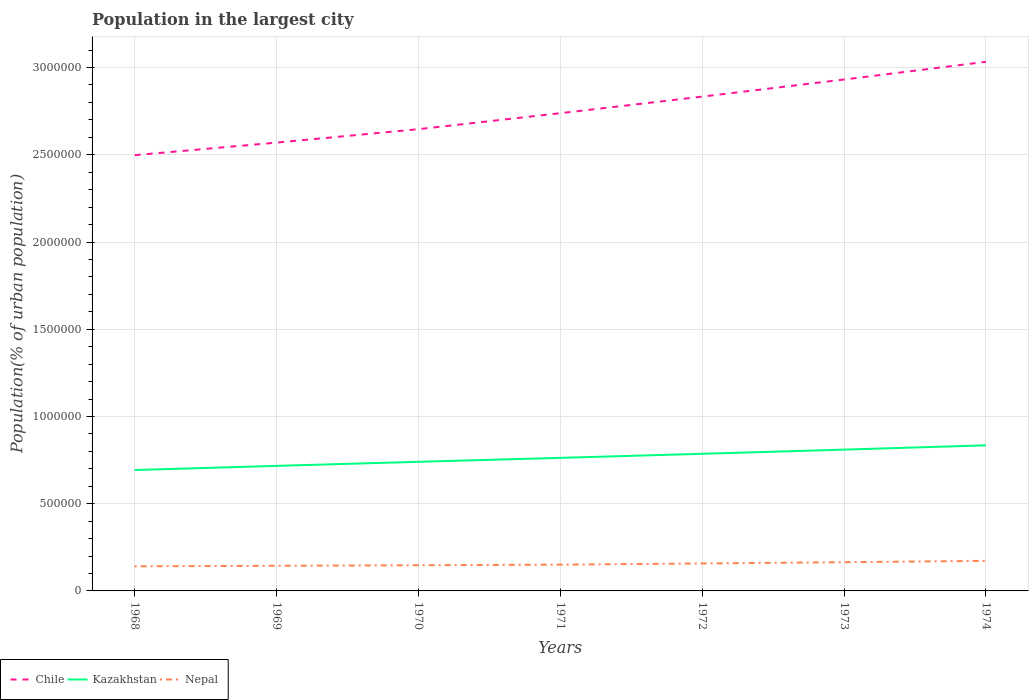Across all years, what is the maximum population in the largest city in Kazakhstan?
Your response must be concise. 6.93e+05. In which year was the population in the largest city in Nepal maximum?
Provide a succinct answer. 1968. What is the total population in the largest city in Nepal in the graph?
Provide a short and direct response. -2.06e+04. What is the difference between the highest and the second highest population in the largest city in Kazakhstan?
Offer a very short reply. 1.42e+05. Is the population in the largest city in Kazakhstan strictly greater than the population in the largest city in Chile over the years?
Your response must be concise. Yes. How many lines are there?
Offer a terse response. 3. Are the values on the major ticks of Y-axis written in scientific E-notation?
Your response must be concise. No. Does the graph contain any zero values?
Your response must be concise. No. What is the title of the graph?
Your answer should be compact. Population in the largest city. Does "Venezuela" appear as one of the legend labels in the graph?
Give a very brief answer. No. What is the label or title of the Y-axis?
Your response must be concise. Population(% of urban population). What is the Population(% of urban population) of Chile in 1968?
Offer a very short reply. 2.50e+06. What is the Population(% of urban population) of Kazakhstan in 1968?
Make the answer very short. 6.93e+05. What is the Population(% of urban population) of Nepal in 1968?
Give a very brief answer. 1.41e+05. What is the Population(% of urban population) in Chile in 1969?
Offer a terse response. 2.57e+06. What is the Population(% of urban population) in Kazakhstan in 1969?
Provide a short and direct response. 7.17e+05. What is the Population(% of urban population) in Nepal in 1969?
Make the answer very short. 1.44e+05. What is the Population(% of urban population) in Chile in 1970?
Make the answer very short. 2.65e+06. What is the Population(% of urban population) in Kazakhstan in 1970?
Your answer should be very brief. 7.40e+05. What is the Population(% of urban population) of Nepal in 1970?
Provide a short and direct response. 1.47e+05. What is the Population(% of urban population) of Chile in 1971?
Offer a very short reply. 2.74e+06. What is the Population(% of urban population) in Kazakhstan in 1971?
Ensure brevity in your answer.  7.63e+05. What is the Population(% of urban population) of Nepal in 1971?
Make the answer very short. 1.51e+05. What is the Population(% of urban population) of Chile in 1972?
Make the answer very short. 2.83e+06. What is the Population(% of urban population) of Kazakhstan in 1972?
Provide a succinct answer. 7.86e+05. What is the Population(% of urban population) in Nepal in 1972?
Give a very brief answer. 1.57e+05. What is the Population(% of urban population) of Chile in 1973?
Your response must be concise. 2.93e+06. What is the Population(% of urban population) of Kazakhstan in 1973?
Your answer should be compact. 8.10e+05. What is the Population(% of urban population) of Nepal in 1973?
Keep it short and to the point. 1.65e+05. What is the Population(% of urban population) of Chile in 1974?
Give a very brief answer. 3.03e+06. What is the Population(% of urban population) in Kazakhstan in 1974?
Provide a short and direct response. 8.35e+05. What is the Population(% of urban population) in Nepal in 1974?
Your response must be concise. 1.72e+05. Across all years, what is the maximum Population(% of urban population) of Chile?
Make the answer very short. 3.03e+06. Across all years, what is the maximum Population(% of urban population) of Kazakhstan?
Offer a terse response. 8.35e+05. Across all years, what is the maximum Population(% of urban population) in Nepal?
Offer a very short reply. 1.72e+05. Across all years, what is the minimum Population(% of urban population) of Chile?
Provide a succinct answer. 2.50e+06. Across all years, what is the minimum Population(% of urban population) in Kazakhstan?
Keep it short and to the point. 6.93e+05. Across all years, what is the minimum Population(% of urban population) of Nepal?
Your response must be concise. 1.41e+05. What is the total Population(% of urban population) in Chile in the graph?
Provide a short and direct response. 1.93e+07. What is the total Population(% of urban population) in Kazakhstan in the graph?
Offer a very short reply. 5.34e+06. What is the total Population(% of urban population) in Nepal in the graph?
Give a very brief answer. 1.08e+06. What is the difference between the Population(% of urban population) in Chile in 1968 and that in 1969?
Provide a succinct answer. -7.19e+04. What is the difference between the Population(% of urban population) of Kazakhstan in 1968 and that in 1969?
Offer a terse response. -2.38e+04. What is the difference between the Population(% of urban population) of Nepal in 1968 and that in 1969?
Provide a succinct answer. -3094. What is the difference between the Population(% of urban population) in Chile in 1968 and that in 1970?
Your response must be concise. -1.49e+05. What is the difference between the Population(% of urban population) of Kazakhstan in 1968 and that in 1970?
Give a very brief answer. -4.72e+04. What is the difference between the Population(% of urban population) in Nepal in 1968 and that in 1970?
Offer a terse response. -6260. What is the difference between the Population(% of urban population) of Chile in 1968 and that in 1971?
Ensure brevity in your answer.  -2.41e+05. What is the difference between the Population(% of urban population) of Kazakhstan in 1968 and that in 1971?
Ensure brevity in your answer.  -6.98e+04. What is the difference between the Population(% of urban population) of Nepal in 1968 and that in 1971?
Your answer should be very brief. -9581. What is the difference between the Population(% of urban population) in Chile in 1968 and that in 1972?
Keep it short and to the point. -3.36e+05. What is the difference between the Population(% of urban population) in Kazakhstan in 1968 and that in 1972?
Your answer should be very brief. -9.30e+04. What is the difference between the Population(% of urban population) in Nepal in 1968 and that in 1972?
Offer a very short reply. -1.65e+04. What is the difference between the Population(% of urban population) of Chile in 1968 and that in 1973?
Give a very brief answer. -4.34e+05. What is the difference between the Population(% of urban population) in Kazakhstan in 1968 and that in 1973?
Your answer should be very brief. -1.17e+05. What is the difference between the Population(% of urban population) of Nepal in 1968 and that in 1973?
Provide a succinct answer. -2.37e+04. What is the difference between the Population(% of urban population) in Chile in 1968 and that in 1974?
Offer a terse response. -5.35e+05. What is the difference between the Population(% of urban population) in Kazakhstan in 1968 and that in 1974?
Your answer should be compact. -1.42e+05. What is the difference between the Population(% of urban population) of Nepal in 1968 and that in 1974?
Give a very brief answer. -3.12e+04. What is the difference between the Population(% of urban population) in Chile in 1969 and that in 1970?
Ensure brevity in your answer.  -7.69e+04. What is the difference between the Population(% of urban population) in Kazakhstan in 1969 and that in 1970?
Your answer should be very brief. -2.34e+04. What is the difference between the Population(% of urban population) in Nepal in 1969 and that in 1970?
Your answer should be very brief. -3166. What is the difference between the Population(% of urban population) of Chile in 1969 and that in 1971?
Keep it short and to the point. -1.69e+05. What is the difference between the Population(% of urban population) in Kazakhstan in 1969 and that in 1971?
Make the answer very short. -4.59e+04. What is the difference between the Population(% of urban population) of Nepal in 1969 and that in 1971?
Ensure brevity in your answer.  -6487. What is the difference between the Population(% of urban population) of Chile in 1969 and that in 1972?
Offer a very short reply. -2.64e+05. What is the difference between the Population(% of urban population) in Kazakhstan in 1969 and that in 1972?
Provide a short and direct response. -6.92e+04. What is the difference between the Population(% of urban population) of Nepal in 1969 and that in 1972?
Your response must be concise. -1.34e+04. What is the difference between the Population(% of urban population) of Chile in 1969 and that in 1973?
Your answer should be very brief. -3.62e+05. What is the difference between the Population(% of urban population) in Kazakhstan in 1969 and that in 1973?
Offer a very short reply. -9.32e+04. What is the difference between the Population(% of urban population) of Nepal in 1969 and that in 1973?
Offer a very short reply. -2.06e+04. What is the difference between the Population(% of urban population) of Chile in 1969 and that in 1974?
Your response must be concise. -4.63e+05. What is the difference between the Population(% of urban population) in Kazakhstan in 1969 and that in 1974?
Your answer should be compact. -1.18e+05. What is the difference between the Population(% of urban population) in Nepal in 1969 and that in 1974?
Provide a succinct answer. -2.81e+04. What is the difference between the Population(% of urban population) in Chile in 1970 and that in 1971?
Offer a very short reply. -9.17e+04. What is the difference between the Population(% of urban population) of Kazakhstan in 1970 and that in 1971?
Ensure brevity in your answer.  -2.26e+04. What is the difference between the Population(% of urban population) in Nepal in 1970 and that in 1971?
Your response must be concise. -3321. What is the difference between the Population(% of urban population) of Chile in 1970 and that in 1972?
Keep it short and to the point. -1.87e+05. What is the difference between the Population(% of urban population) in Kazakhstan in 1970 and that in 1972?
Provide a succinct answer. -4.59e+04. What is the difference between the Population(% of urban population) in Nepal in 1970 and that in 1972?
Your answer should be very brief. -1.02e+04. What is the difference between the Population(% of urban population) in Chile in 1970 and that in 1973?
Make the answer very short. -2.85e+05. What is the difference between the Population(% of urban population) of Kazakhstan in 1970 and that in 1973?
Provide a short and direct response. -6.98e+04. What is the difference between the Population(% of urban population) of Nepal in 1970 and that in 1973?
Your response must be concise. -1.74e+04. What is the difference between the Population(% of urban population) of Chile in 1970 and that in 1974?
Ensure brevity in your answer.  -3.86e+05. What is the difference between the Population(% of urban population) of Kazakhstan in 1970 and that in 1974?
Ensure brevity in your answer.  -9.45e+04. What is the difference between the Population(% of urban population) in Nepal in 1970 and that in 1974?
Provide a short and direct response. -2.49e+04. What is the difference between the Population(% of urban population) in Chile in 1971 and that in 1972?
Offer a very short reply. -9.50e+04. What is the difference between the Population(% of urban population) in Kazakhstan in 1971 and that in 1972?
Keep it short and to the point. -2.33e+04. What is the difference between the Population(% of urban population) of Nepal in 1971 and that in 1972?
Your answer should be compact. -6892. What is the difference between the Population(% of urban population) of Chile in 1971 and that in 1973?
Your response must be concise. -1.93e+05. What is the difference between the Population(% of urban population) of Kazakhstan in 1971 and that in 1973?
Keep it short and to the point. -4.72e+04. What is the difference between the Population(% of urban population) in Nepal in 1971 and that in 1973?
Ensure brevity in your answer.  -1.41e+04. What is the difference between the Population(% of urban population) in Chile in 1971 and that in 1974?
Your response must be concise. -2.95e+05. What is the difference between the Population(% of urban population) of Kazakhstan in 1971 and that in 1974?
Your answer should be very brief. -7.19e+04. What is the difference between the Population(% of urban population) in Nepal in 1971 and that in 1974?
Your answer should be very brief. -2.16e+04. What is the difference between the Population(% of urban population) of Chile in 1972 and that in 1973?
Keep it short and to the point. -9.80e+04. What is the difference between the Population(% of urban population) in Kazakhstan in 1972 and that in 1973?
Your response must be concise. -2.39e+04. What is the difference between the Population(% of urban population) in Nepal in 1972 and that in 1973?
Make the answer very short. -7187. What is the difference between the Population(% of urban population) in Chile in 1972 and that in 1974?
Ensure brevity in your answer.  -2.00e+05. What is the difference between the Population(% of urban population) in Kazakhstan in 1972 and that in 1974?
Keep it short and to the point. -4.86e+04. What is the difference between the Population(% of urban population) of Nepal in 1972 and that in 1974?
Ensure brevity in your answer.  -1.47e+04. What is the difference between the Population(% of urban population) in Chile in 1973 and that in 1974?
Your answer should be compact. -1.02e+05. What is the difference between the Population(% of urban population) in Kazakhstan in 1973 and that in 1974?
Provide a succinct answer. -2.47e+04. What is the difference between the Population(% of urban population) of Nepal in 1973 and that in 1974?
Offer a very short reply. -7526. What is the difference between the Population(% of urban population) in Chile in 1968 and the Population(% of urban population) in Kazakhstan in 1969?
Offer a very short reply. 1.78e+06. What is the difference between the Population(% of urban population) of Chile in 1968 and the Population(% of urban population) of Nepal in 1969?
Your response must be concise. 2.35e+06. What is the difference between the Population(% of urban population) in Kazakhstan in 1968 and the Population(% of urban population) in Nepal in 1969?
Provide a succinct answer. 5.49e+05. What is the difference between the Population(% of urban population) in Chile in 1968 and the Population(% of urban population) in Kazakhstan in 1970?
Your answer should be very brief. 1.76e+06. What is the difference between the Population(% of urban population) of Chile in 1968 and the Population(% of urban population) of Nepal in 1970?
Make the answer very short. 2.35e+06. What is the difference between the Population(% of urban population) of Kazakhstan in 1968 and the Population(% of urban population) of Nepal in 1970?
Provide a short and direct response. 5.46e+05. What is the difference between the Population(% of urban population) of Chile in 1968 and the Population(% of urban population) of Kazakhstan in 1971?
Your answer should be compact. 1.74e+06. What is the difference between the Population(% of urban population) in Chile in 1968 and the Population(% of urban population) in Nepal in 1971?
Your answer should be compact. 2.35e+06. What is the difference between the Population(% of urban population) in Kazakhstan in 1968 and the Population(% of urban population) in Nepal in 1971?
Your response must be concise. 5.42e+05. What is the difference between the Population(% of urban population) in Chile in 1968 and the Population(% of urban population) in Kazakhstan in 1972?
Provide a short and direct response. 1.71e+06. What is the difference between the Population(% of urban population) in Chile in 1968 and the Population(% of urban population) in Nepal in 1972?
Offer a terse response. 2.34e+06. What is the difference between the Population(% of urban population) in Kazakhstan in 1968 and the Population(% of urban population) in Nepal in 1972?
Provide a short and direct response. 5.35e+05. What is the difference between the Population(% of urban population) in Chile in 1968 and the Population(% of urban population) in Kazakhstan in 1973?
Provide a short and direct response. 1.69e+06. What is the difference between the Population(% of urban population) in Chile in 1968 and the Population(% of urban population) in Nepal in 1973?
Your answer should be very brief. 2.33e+06. What is the difference between the Population(% of urban population) of Kazakhstan in 1968 and the Population(% of urban population) of Nepal in 1973?
Ensure brevity in your answer.  5.28e+05. What is the difference between the Population(% of urban population) of Chile in 1968 and the Population(% of urban population) of Kazakhstan in 1974?
Ensure brevity in your answer.  1.66e+06. What is the difference between the Population(% of urban population) of Chile in 1968 and the Population(% of urban population) of Nepal in 1974?
Offer a very short reply. 2.33e+06. What is the difference between the Population(% of urban population) in Kazakhstan in 1968 and the Population(% of urban population) in Nepal in 1974?
Provide a succinct answer. 5.21e+05. What is the difference between the Population(% of urban population) of Chile in 1969 and the Population(% of urban population) of Kazakhstan in 1970?
Make the answer very short. 1.83e+06. What is the difference between the Population(% of urban population) of Chile in 1969 and the Population(% of urban population) of Nepal in 1970?
Provide a succinct answer. 2.42e+06. What is the difference between the Population(% of urban population) in Kazakhstan in 1969 and the Population(% of urban population) in Nepal in 1970?
Provide a succinct answer. 5.69e+05. What is the difference between the Population(% of urban population) in Chile in 1969 and the Population(% of urban population) in Kazakhstan in 1971?
Give a very brief answer. 1.81e+06. What is the difference between the Population(% of urban population) of Chile in 1969 and the Population(% of urban population) of Nepal in 1971?
Provide a succinct answer. 2.42e+06. What is the difference between the Population(% of urban population) of Kazakhstan in 1969 and the Population(% of urban population) of Nepal in 1971?
Give a very brief answer. 5.66e+05. What is the difference between the Population(% of urban population) in Chile in 1969 and the Population(% of urban population) in Kazakhstan in 1972?
Ensure brevity in your answer.  1.78e+06. What is the difference between the Population(% of urban population) of Chile in 1969 and the Population(% of urban population) of Nepal in 1972?
Your answer should be very brief. 2.41e+06. What is the difference between the Population(% of urban population) of Kazakhstan in 1969 and the Population(% of urban population) of Nepal in 1972?
Your answer should be very brief. 5.59e+05. What is the difference between the Population(% of urban population) in Chile in 1969 and the Population(% of urban population) in Kazakhstan in 1973?
Provide a succinct answer. 1.76e+06. What is the difference between the Population(% of urban population) of Chile in 1969 and the Population(% of urban population) of Nepal in 1973?
Your answer should be compact. 2.41e+06. What is the difference between the Population(% of urban population) of Kazakhstan in 1969 and the Population(% of urban population) of Nepal in 1973?
Make the answer very short. 5.52e+05. What is the difference between the Population(% of urban population) of Chile in 1969 and the Population(% of urban population) of Kazakhstan in 1974?
Offer a terse response. 1.74e+06. What is the difference between the Population(% of urban population) in Chile in 1969 and the Population(% of urban population) in Nepal in 1974?
Provide a short and direct response. 2.40e+06. What is the difference between the Population(% of urban population) of Kazakhstan in 1969 and the Population(% of urban population) of Nepal in 1974?
Offer a terse response. 5.45e+05. What is the difference between the Population(% of urban population) in Chile in 1970 and the Population(% of urban population) in Kazakhstan in 1971?
Your answer should be very brief. 1.88e+06. What is the difference between the Population(% of urban population) of Chile in 1970 and the Population(% of urban population) of Nepal in 1971?
Ensure brevity in your answer.  2.50e+06. What is the difference between the Population(% of urban population) of Kazakhstan in 1970 and the Population(% of urban population) of Nepal in 1971?
Provide a succinct answer. 5.90e+05. What is the difference between the Population(% of urban population) of Chile in 1970 and the Population(% of urban population) of Kazakhstan in 1972?
Offer a terse response. 1.86e+06. What is the difference between the Population(% of urban population) in Chile in 1970 and the Population(% of urban population) in Nepal in 1972?
Provide a short and direct response. 2.49e+06. What is the difference between the Population(% of urban population) in Kazakhstan in 1970 and the Population(% of urban population) in Nepal in 1972?
Your answer should be compact. 5.83e+05. What is the difference between the Population(% of urban population) in Chile in 1970 and the Population(% of urban population) in Kazakhstan in 1973?
Make the answer very short. 1.84e+06. What is the difference between the Population(% of urban population) in Chile in 1970 and the Population(% of urban population) in Nepal in 1973?
Your answer should be compact. 2.48e+06. What is the difference between the Population(% of urban population) of Kazakhstan in 1970 and the Population(% of urban population) of Nepal in 1973?
Give a very brief answer. 5.75e+05. What is the difference between the Population(% of urban population) of Chile in 1970 and the Population(% of urban population) of Kazakhstan in 1974?
Make the answer very short. 1.81e+06. What is the difference between the Population(% of urban population) of Chile in 1970 and the Population(% of urban population) of Nepal in 1974?
Your answer should be very brief. 2.47e+06. What is the difference between the Population(% of urban population) in Kazakhstan in 1970 and the Population(% of urban population) in Nepal in 1974?
Provide a short and direct response. 5.68e+05. What is the difference between the Population(% of urban population) in Chile in 1971 and the Population(% of urban population) in Kazakhstan in 1972?
Keep it short and to the point. 1.95e+06. What is the difference between the Population(% of urban population) of Chile in 1971 and the Population(% of urban population) of Nepal in 1972?
Keep it short and to the point. 2.58e+06. What is the difference between the Population(% of urban population) in Kazakhstan in 1971 and the Population(% of urban population) in Nepal in 1972?
Offer a terse response. 6.05e+05. What is the difference between the Population(% of urban population) in Chile in 1971 and the Population(% of urban population) in Kazakhstan in 1973?
Give a very brief answer. 1.93e+06. What is the difference between the Population(% of urban population) of Chile in 1971 and the Population(% of urban population) of Nepal in 1973?
Give a very brief answer. 2.57e+06. What is the difference between the Population(% of urban population) in Kazakhstan in 1971 and the Population(% of urban population) in Nepal in 1973?
Make the answer very short. 5.98e+05. What is the difference between the Population(% of urban population) of Chile in 1971 and the Population(% of urban population) of Kazakhstan in 1974?
Ensure brevity in your answer.  1.90e+06. What is the difference between the Population(% of urban population) of Chile in 1971 and the Population(% of urban population) of Nepal in 1974?
Offer a terse response. 2.57e+06. What is the difference between the Population(% of urban population) in Kazakhstan in 1971 and the Population(% of urban population) in Nepal in 1974?
Make the answer very short. 5.91e+05. What is the difference between the Population(% of urban population) in Chile in 1972 and the Population(% of urban population) in Kazakhstan in 1973?
Provide a short and direct response. 2.02e+06. What is the difference between the Population(% of urban population) of Chile in 1972 and the Population(% of urban population) of Nepal in 1973?
Your response must be concise. 2.67e+06. What is the difference between the Population(% of urban population) in Kazakhstan in 1972 and the Population(% of urban population) in Nepal in 1973?
Ensure brevity in your answer.  6.21e+05. What is the difference between the Population(% of urban population) of Chile in 1972 and the Population(% of urban population) of Kazakhstan in 1974?
Make the answer very short. 2.00e+06. What is the difference between the Population(% of urban population) of Chile in 1972 and the Population(% of urban population) of Nepal in 1974?
Provide a short and direct response. 2.66e+06. What is the difference between the Population(% of urban population) in Kazakhstan in 1972 and the Population(% of urban population) in Nepal in 1974?
Ensure brevity in your answer.  6.14e+05. What is the difference between the Population(% of urban population) in Chile in 1973 and the Population(% of urban population) in Kazakhstan in 1974?
Your answer should be compact. 2.10e+06. What is the difference between the Population(% of urban population) of Chile in 1973 and the Population(% of urban population) of Nepal in 1974?
Give a very brief answer. 2.76e+06. What is the difference between the Population(% of urban population) of Kazakhstan in 1973 and the Population(% of urban population) of Nepal in 1974?
Provide a succinct answer. 6.38e+05. What is the average Population(% of urban population) of Chile per year?
Your answer should be compact. 2.75e+06. What is the average Population(% of urban population) of Kazakhstan per year?
Keep it short and to the point. 7.63e+05. What is the average Population(% of urban population) of Nepal per year?
Provide a succinct answer. 1.54e+05. In the year 1968, what is the difference between the Population(% of urban population) of Chile and Population(% of urban population) of Kazakhstan?
Offer a very short reply. 1.80e+06. In the year 1968, what is the difference between the Population(% of urban population) of Chile and Population(% of urban population) of Nepal?
Keep it short and to the point. 2.36e+06. In the year 1968, what is the difference between the Population(% of urban population) of Kazakhstan and Population(% of urban population) of Nepal?
Your answer should be very brief. 5.52e+05. In the year 1969, what is the difference between the Population(% of urban population) in Chile and Population(% of urban population) in Kazakhstan?
Provide a succinct answer. 1.85e+06. In the year 1969, what is the difference between the Population(% of urban population) of Chile and Population(% of urban population) of Nepal?
Give a very brief answer. 2.43e+06. In the year 1969, what is the difference between the Population(% of urban population) in Kazakhstan and Population(% of urban population) in Nepal?
Make the answer very short. 5.73e+05. In the year 1970, what is the difference between the Population(% of urban population) in Chile and Population(% of urban population) in Kazakhstan?
Give a very brief answer. 1.91e+06. In the year 1970, what is the difference between the Population(% of urban population) of Chile and Population(% of urban population) of Nepal?
Keep it short and to the point. 2.50e+06. In the year 1970, what is the difference between the Population(% of urban population) in Kazakhstan and Population(% of urban population) in Nepal?
Make the answer very short. 5.93e+05. In the year 1971, what is the difference between the Population(% of urban population) of Chile and Population(% of urban population) of Kazakhstan?
Your answer should be very brief. 1.98e+06. In the year 1971, what is the difference between the Population(% of urban population) in Chile and Population(% of urban population) in Nepal?
Give a very brief answer. 2.59e+06. In the year 1971, what is the difference between the Population(% of urban population) in Kazakhstan and Population(% of urban population) in Nepal?
Ensure brevity in your answer.  6.12e+05. In the year 1972, what is the difference between the Population(% of urban population) of Chile and Population(% of urban population) of Kazakhstan?
Your answer should be very brief. 2.05e+06. In the year 1972, what is the difference between the Population(% of urban population) of Chile and Population(% of urban population) of Nepal?
Make the answer very short. 2.68e+06. In the year 1972, what is the difference between the Population(% of urban population) of Kazakhstan and Population(% of urban population) of Nepal?
Give a very brief answer. 6.29e+05. In the year 1973, what is the difference between the Population(% of urban population) in Chile and Population(% of urban population) in Kazakhstan?
Your answer should be very brief. 2.12e+06. In the year 1973, what is the difference between the Population(% of urban population) in Chile and Population(% of urban population) in Nepal?
Provide a short and direct response. 2.77e+06. In the year 1973, what is the difference between the Population(% of urban population) in Kazakhstan and Population(% of urban population) in Nepal?
Your answer should be compact. 6.45e+05. In the year 1974, what is the difference between the Population(% of urban population) in Chile and Population(% of urban population) in Kazakhstan?
Offer a terse response. 2.20e+06. In the year 1974, what is the difference between the Population(% of urban population) of Chile and Population(% of urban population) of Nepal?
Keep it short and to the point. 2.86e+06. In the year 1974, what is the difference between the Population(% of urban population) of Kazakhstan and Population(% of urban population) of Nepal?
Make the answer very short. 6.62e+05. What is the ratio of the Population(% of urban population) in Kazakhstan in 1968 to that in 1969?
Ensure brevity in your answer.  0.97. What is the ratio of the Population(% of urban population) of Nepal in 1968 to that in 1969?
Provide a succinct answer. 0.98. What is the ratio of the Population(% of urban population) in Chile in 1968 to that in 1970?
Give a very brief answer. 0.94. What is the ratio of the Population(% of urban population) in Kazakhstan in 1968 to that in 1970?
Provide a short and direct response. 0.94. What is the ratio of the Population(% of urban population) in Nepal in 1968 to that in 1970?
Your answer should be very brief. 0.96. What is the ratio of the Population(% of urban population) in Chile in 1968 to that in 1971?
Provide a succinct answer. 0.91. What is the ratio of the Population(% of urban population) of Kazakhstan in 1968 to that in 1971?
Your answer should be very brief. 0.91. What is the ratio of the Population(% of urban population) of Nepal in 1968 to that in 1971?
Provide a succinct answer. 0.94. What is the ratio of the Population(% of urban population) in Chile in 1968 to that in 1972?
Ensure brevity in your answer.  0.88. What is the ratio of the Population(% of urban population) of Kazakhstan in 1968 to that in 1972?
Provide a succinct answer. 0.88. What is the ratio of the Population(% of urban population) of Nepal in 1968 to that in 1972?
Offer a terse response. 0.9. What is the ratio of the Population(% of urban population) of Chile in 1968 to that in 1973?
Keep it short and to the point. 0.85. What is the ratio of the Population(% of urban population) in Kazakhstan in 1968 to that in 1973?
Offer a very short reply. 0.86. What is the ratio of the Population(% of urban population) of Nepal in 1968 to that in 1973?
Offer a very short reply. 0.86. What is the ratio of the Population(% of urban population) of Chile in 1968 to that in 1974?
Provide a short and direct response. 0.82. What is the ratio of the Population(% of urban population) in Kazakhstan in 1968 to that in 1974?
Your answer should be compact. 0.83. What is the ratio of the Population(% of urban population) of Nepal in 1968 to that in 1974?
Provide a short and direct response. 0.82. What is the ratio of the Population(% of urban population) in Chile in 1969 to that in 1970?
Your response must be concise. 0.97. What is the ratio of the Population(% of urban population) of Kazakhstan in 1969 to that in 1970?
Your response must be concise. 0.97. What is the ratio of the Population(% of urban population) in Nepal in 1969 to that in 1970?
Your response must be concise. 0.98. What is the ratio of the Population(% of urban population) of Chile in 1969 to that in 1971?
Provide a succinct answer. 0.94. What is the ratio of the Population(% of urban population) in Kazakhstan in 1969 to that in 1971?
Your response must be concise. 0.94. What is the ratio of the Population(% of urban population) in Nepal in 1969 to that in 1971?
Your response must be concise. 0.96. What is the ratio of the Population(% of urban population) in Chile in 1969 to that in 1972?
Make the answer very short. 0.91. What is the ratio of the Population(% of urban population) in Kazakhstan in 1969 to that in 1972?
Keep it short and to the point. 0.91. What is the ratio of the Population(% of urban population) of Nepal in 1969 to that in 1972?
Your answer should be compact. 0.92. What is the ratio of the Population(% of urban population) in Chile in 1969 to that in 1973?
Ensure brevity in your answer.  0.88. What is the ratio of the Population(% of urban population) in Kazakhstan in 1969 to that in 1973?
Keep it short and to the point. 0.89. What is the ratio of the Population(% of urban population) in Nepal in 1969 to that in 1973?
Provide a short and direct response. 0.88. What is the ratio of the Population(% of urban population) in Chile in 1969 to that in 1974?
Offer a terse response. 0.85. What is the ratio of the Population(% of urban population) in Kazakhstan in 1969 to that in 1974?
Offer a terse response. 0.86. What is the ratio of the Population(% of urban population) of Nepal in 1969 to that in 1974?
Offer a terse response. 0.84. What is the ratio of the Population(% of urban population) in Chile in 1970 to that in 1971?
Give a very brief answer. 0.97. What is the ratio of the Population(% of urban population) of Kazakhstan in 1970 to that in 1971?
Give a very brief answer. 0.97. What is the ratio of the Population(% of urban population) in Nepal in 1970 to that in 1971?
Your answer should be compact. 0.98. What is the ratio of the Population(% of urban population) in Chile in 1970 to that in 1972?
Your answer should be compact. 0.93. What is the ratio of the Population(% of urban population) in Kazakhstan in 1970 to that in 1972?
Ensure brevity in your answer.  0.94. What is the ratio of the Population(% of urban population) in Nepal in 1970 to that in 1972?
Keep it short and to the point. 0.94. What is the ratio of the Population(% of urban population) of Chile in 1970 to that in 1973?
Offer a terse response. 0.9. What is the ratio of the Population(% of urban population) of Kazakhstan in 1970 to that in 1973?
Offer a terse response. 0.91. What is the ratio of the Population(% of urban population) of Nepal in 1970 to that in 1973?
Your answer should be compact. 0.89. What is the ratio of the Population(% of urban population) of Chile in 1970 to that in 1974?
Provide a short and direct response. 0.87. What is the ratio of the Population(% of urban population) in Kazakhstan in 1970 to that in 1974?
Provide a short and direct response. 0.89. What is the ratio of the Population(% of urban population) of Nepal in 1970 to that in 1974?
Give a very brief answer. 0.86. What is the ratio of the Population(% of urban population) in Chile in 1971 to that in 1972?
Offer a terse response. 0.97. What is the ratio of the Population(% of urban population) of Kazakhstan in 1971 to that in 1972?
Give a very brief answer. 0.97. What is the ratio of the Population(% of urban population) in Nepal in 1971 to that in 1972?
Provide a short and direct response. 0.96. What is the ratio of the Population(% of urban population) in Chile in 1971 to that in 1973?
Offer a terse response. 0.93. What is the ratio of the Population(% of urban population) in Kazakhstan in 1971 to that in 1973?
Keep it short and to the point. 0.94. What is the ratio of the Population(% of urban population) of Nepal in 1971 to that in 1973?
Your answer should be very brief. 0.91. What is the ratio of the Population(% of urban population) of Chile in 1971 to that in 1974?
Provide a short and direct response. 0.9. What is the ratio of the Population(% of urban population) of Kazakhstan in 1971 to that in 1974?
Provide a succinct answer. 0.91. What is the ratio of the Population(% of urban population) of Nepal in 1971 to that in 1974?
Your response must be concise. 0.87. What is the ratio of the Population(% of urban population) of Chile in 1972 to that in 1973?
Offer a very short reply. 0.97. What is the ratio of the Population(% of urban population) in Kazakhstan in 1972 to that in 1973?
Give a very brief answer. 0.97. What is the ratio of the Population(% of urban population) in Nepal in 1972 to that in 1973?
Offer a very short reply. 0.96. What is the ratio of the Population(% of urban population) of Chile in 1972 to that in 1974?
Offer a very short reply. 0.93. What is the ratio of the Population(% of urban population) of Kazakhstan in 1972 to that in 1974?
Your response must be concise. 0.94. What is the ratio of the Population(% of urban population) of Nepal in 1972 to that in 1974?
Keep it short and to the point. 0.91. What is the ratio of the Population(% of urban population) in Chile in 1973 to that in 1974?
Your answer should be compact. 0.97. What is the ratio of the Population(% of urban population) of Kazakhstan in 1973 to that in 1974?
Offer a very short reply. 0.97. What is the ratio of the Population(% of urban population) of Nepal in 1973 to that in 1974?
Your response must be concise. 0.96. What is the difference between the highest and the second highest Population(% of urban population) in Chile?
Offer a very short reply. 1.02e+05. What is the difference between the highest and the second highest Population(% of urban population) in Kazakhstan?
Your response must be concise. 2.47e+04. What is the difference between the highest and the second highest Population(% of urban population) of Nepal?
Ensure brevity in your answer.  7526. What is the difference between the highest and the lowest Population(% of urban population) of Chile?
Make the answer very short. 5.35e+05. What is the difference between the highest and the lowest Population(% of urban population) in Kazakhstan?
Provide a succinct answer. 1.42e+05. What is the difference between the highest and the lowest Population(% of urban population) in Nepal?
Offer a terse response. 3.12e+04. 